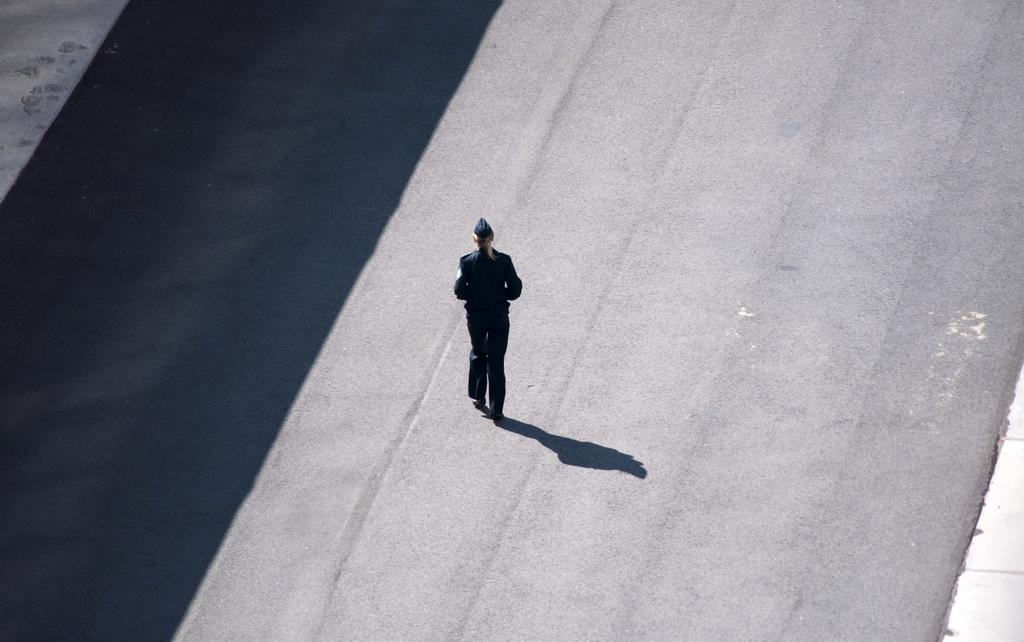What is the main subject of the image? There is a person standing in the image. What is the person wearing? The person is wearing a uniform and a cap. What can be observed on the ground in the image? Shadows are visible on the ground in the image. How many wheels can be seen on the person's knee in the image? There are no wheels or knees visible on the person in the image; they are wearing a uniform and cap. 